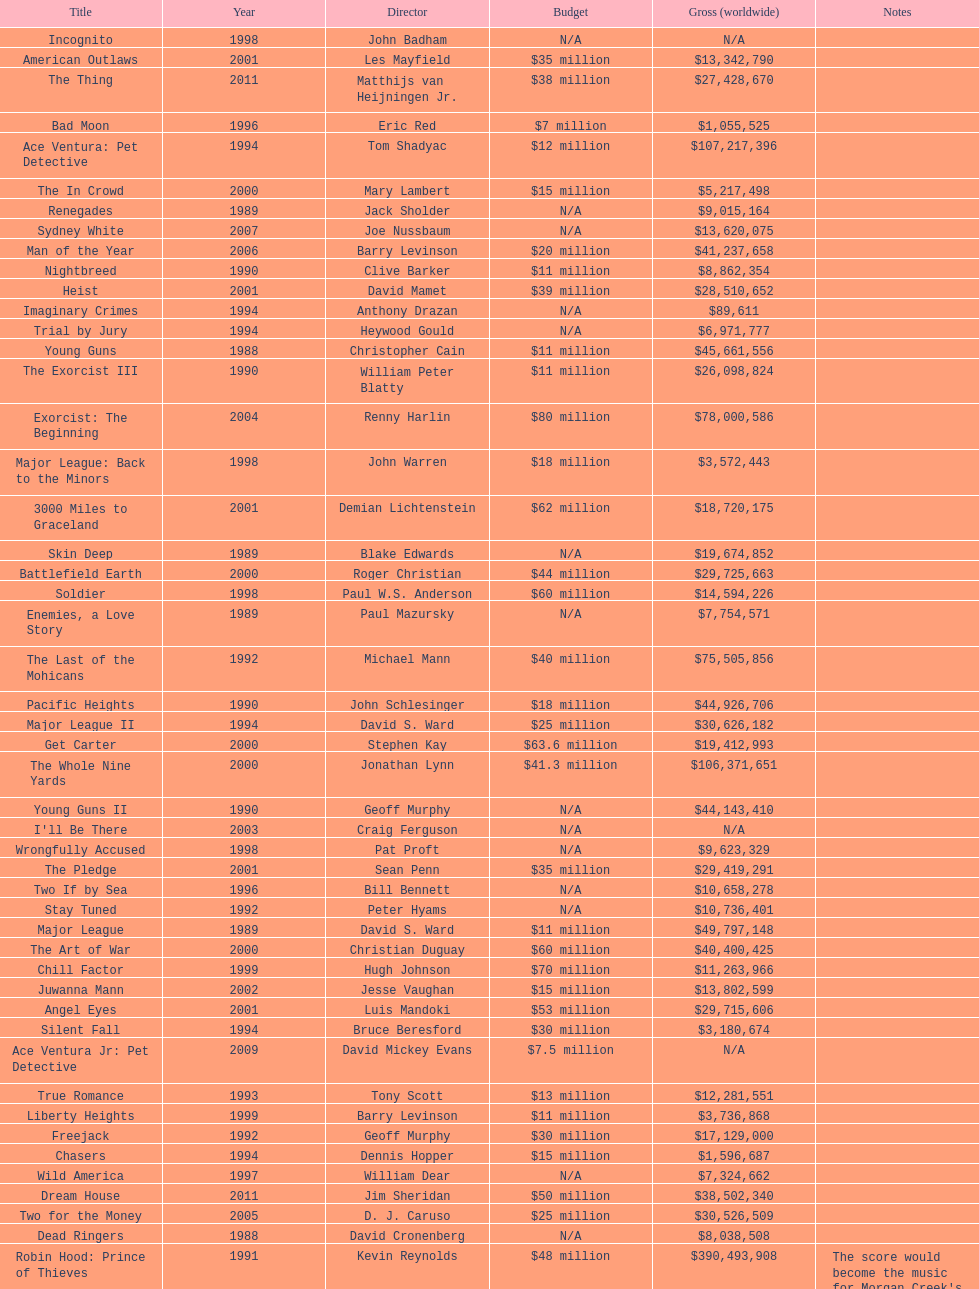How many films did morgan creek make in 2006? 2. 